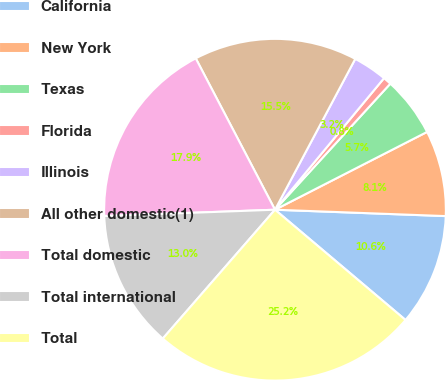Convert chart to OTSL. <chart><loc_0><loc_0><loc_500><loc_500><pie_chart><fcel>California<fcel>New York<fcel>Texas<fcel>Florida<fcel>Illinois<fcel>All other domestic(1)<fcel>Total domestic<fcel>Total international<fcel>Total<nl><fcel>10.57%<fcel>8.12%<fcel>5.68%<fcel>0.78%<fcel>3.23%<fcel>15.46%<fcel>17.91%<fcel>13.01%<fcel>25.24%<nl></chart> 